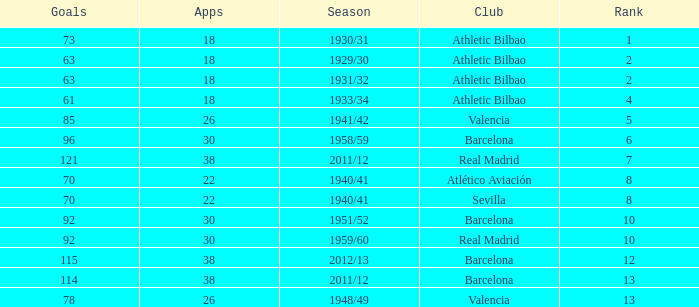How many apps when the rank was after 13 and having more than 73 goals? None. Could you help me parse every detail presented in this table? {'header': ['Goals', 'Apps', 'Season', 'Club', 'Rank'], 'rows': [['73', '18', '1930/31', 'Athletic Bilbao', '1'], ['63', '18', '1929/30', 'Athletic Bilbao', '2'], ['63', '18', '1931/32', 'Athletic Bilbao', '2'], ['61', '18', '1933/34', 'Athletic Bilbao', '4'], ['85', '26', '1941/42', 'Valencia', '5'], ['96', '30', '1958/59', 'Barcelona', '6'], ['121', '38', '2011/12', 'Real Madrid', '7'], ['70', '22', '1940/41', 'Atlético Aviación', '8'], ['70', '22', '1940/41', 'Sevilla', '8'], ['92', '30', '1951/52', 'Barcelona', '10'], ['92', '30', '1959/60', 'Real Madrid', '10'], ['115', '38', '2012/13', 'Barcelona', '12'], ['114', '38', '2011/12', 'Barcelona', '13'], ['78', '26', '1948/49', 'Valencia', '13']]} 